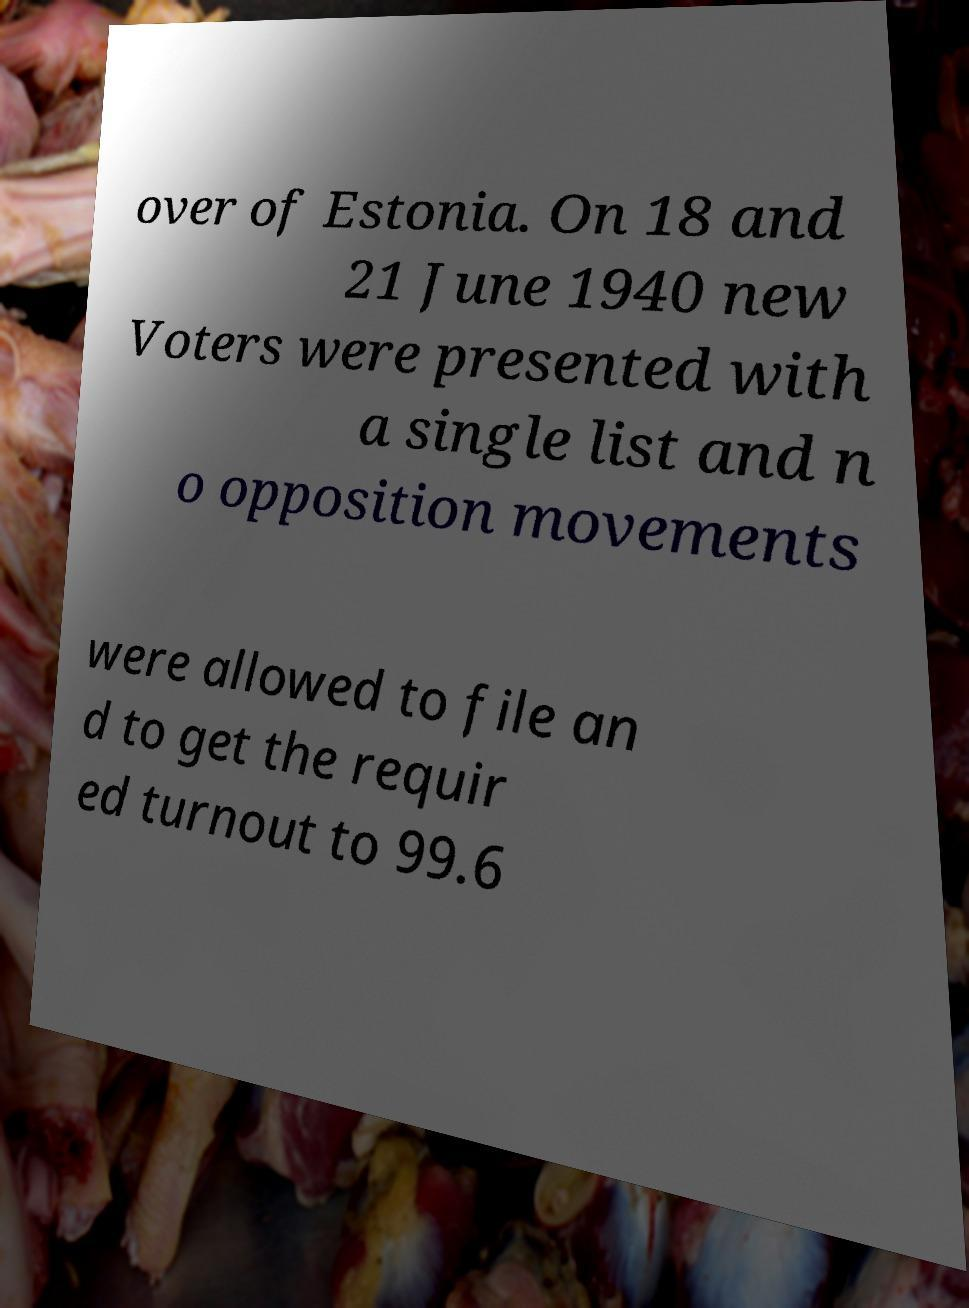Please read and relay the text visible in this image. What does it say? over of Estonia. On 18 and 21 June 1940 new Voters were presented with a single list and n o opposition movements were allowed to file an d to get the requir ed turnout to 99.6 